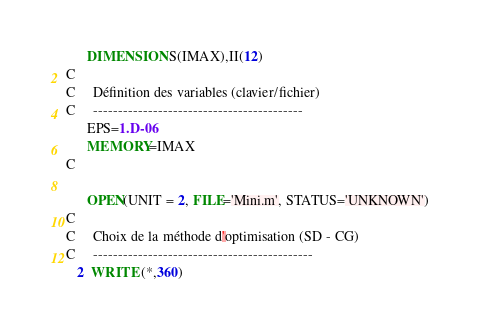<code> <loc_0><loc_0><loc_500><loc_500><_FORTRAN_>      DIMENSION S(IMAX),II(12)
C
C     Définition des variables (clavier/fichier)
C     ------------------------------------------
      EPS=1.D-06
      MEMORY=IMAX
C

      OPEN(UNIT = 2, FILE='Mini.m', STATUS='UNKNOWN')
C
C     Choix de la méthode d'optimisation (SD - CG)
C     --------------------------------------------
   2  WRITE (*,360) </code> 